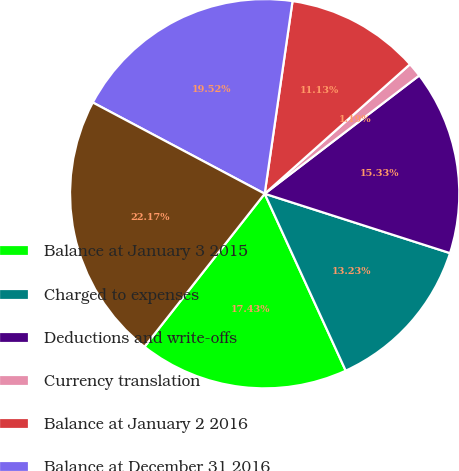Convert chart. <chart><loc_0><loc_0><loc_500><loc_500><pie_chart><fcel>Balance at January 3 2015<fcel>Charged to expenses<fcel>Deductions and write-offs<fcel>Currency translation<fcel>Balance at January 2 2016<fcel>Balance at December 31 2016<fcel>Balance at December 30 2017<nl><fcel>17.43%<fcel>13.23%<fcel>15.33%<fcel>1.19%<fcel>11.13%<fcel>19.52%<fcel>22.17%<nl></chart> 